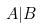<formula> <loc_0><loc_0><loc_500><loc_500>A | B</formula> 